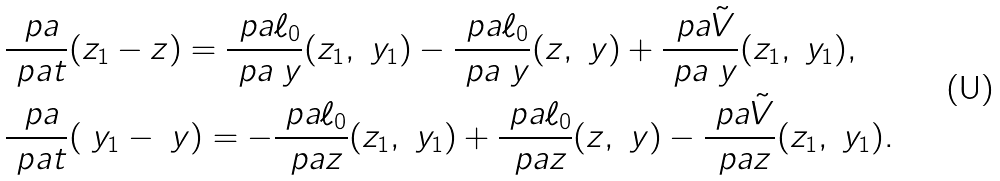<formula> <loc_0><loc_0><loc_500><loc_500>& \frac { \ p a } { \ p a t } ( z _ { 1 } - z ) = \frac { \ p a \ell _ { 0 } } { \ p a \ y } ( z _ { 1 } , \ y _ { 1 } ) - \frac { \ p a \ell _ { 0 } } { \ p a \ y } ( z , \ y ) + \frac { \ p a \tilde { V } } { \ p a \ y } ( z _ { 1 } , \ y _ { 1 } ) , \\ & \frac { \ p a } { \ p a t } ( \ y _ { 1 } - \ y ) = - \frac { \ p a \ell _ { 0 } } { \ p a z } ( z _ { 1 } , \ y _ { 1 } ) + \frac { \ p a \ell _ { 0 } } { \ p a z } ( z , \ y ) - \frac { \ p a \tilde { V } } { \ p a z } ( z _ { 1 } , \ y _ { 1 } ) .</formula> 